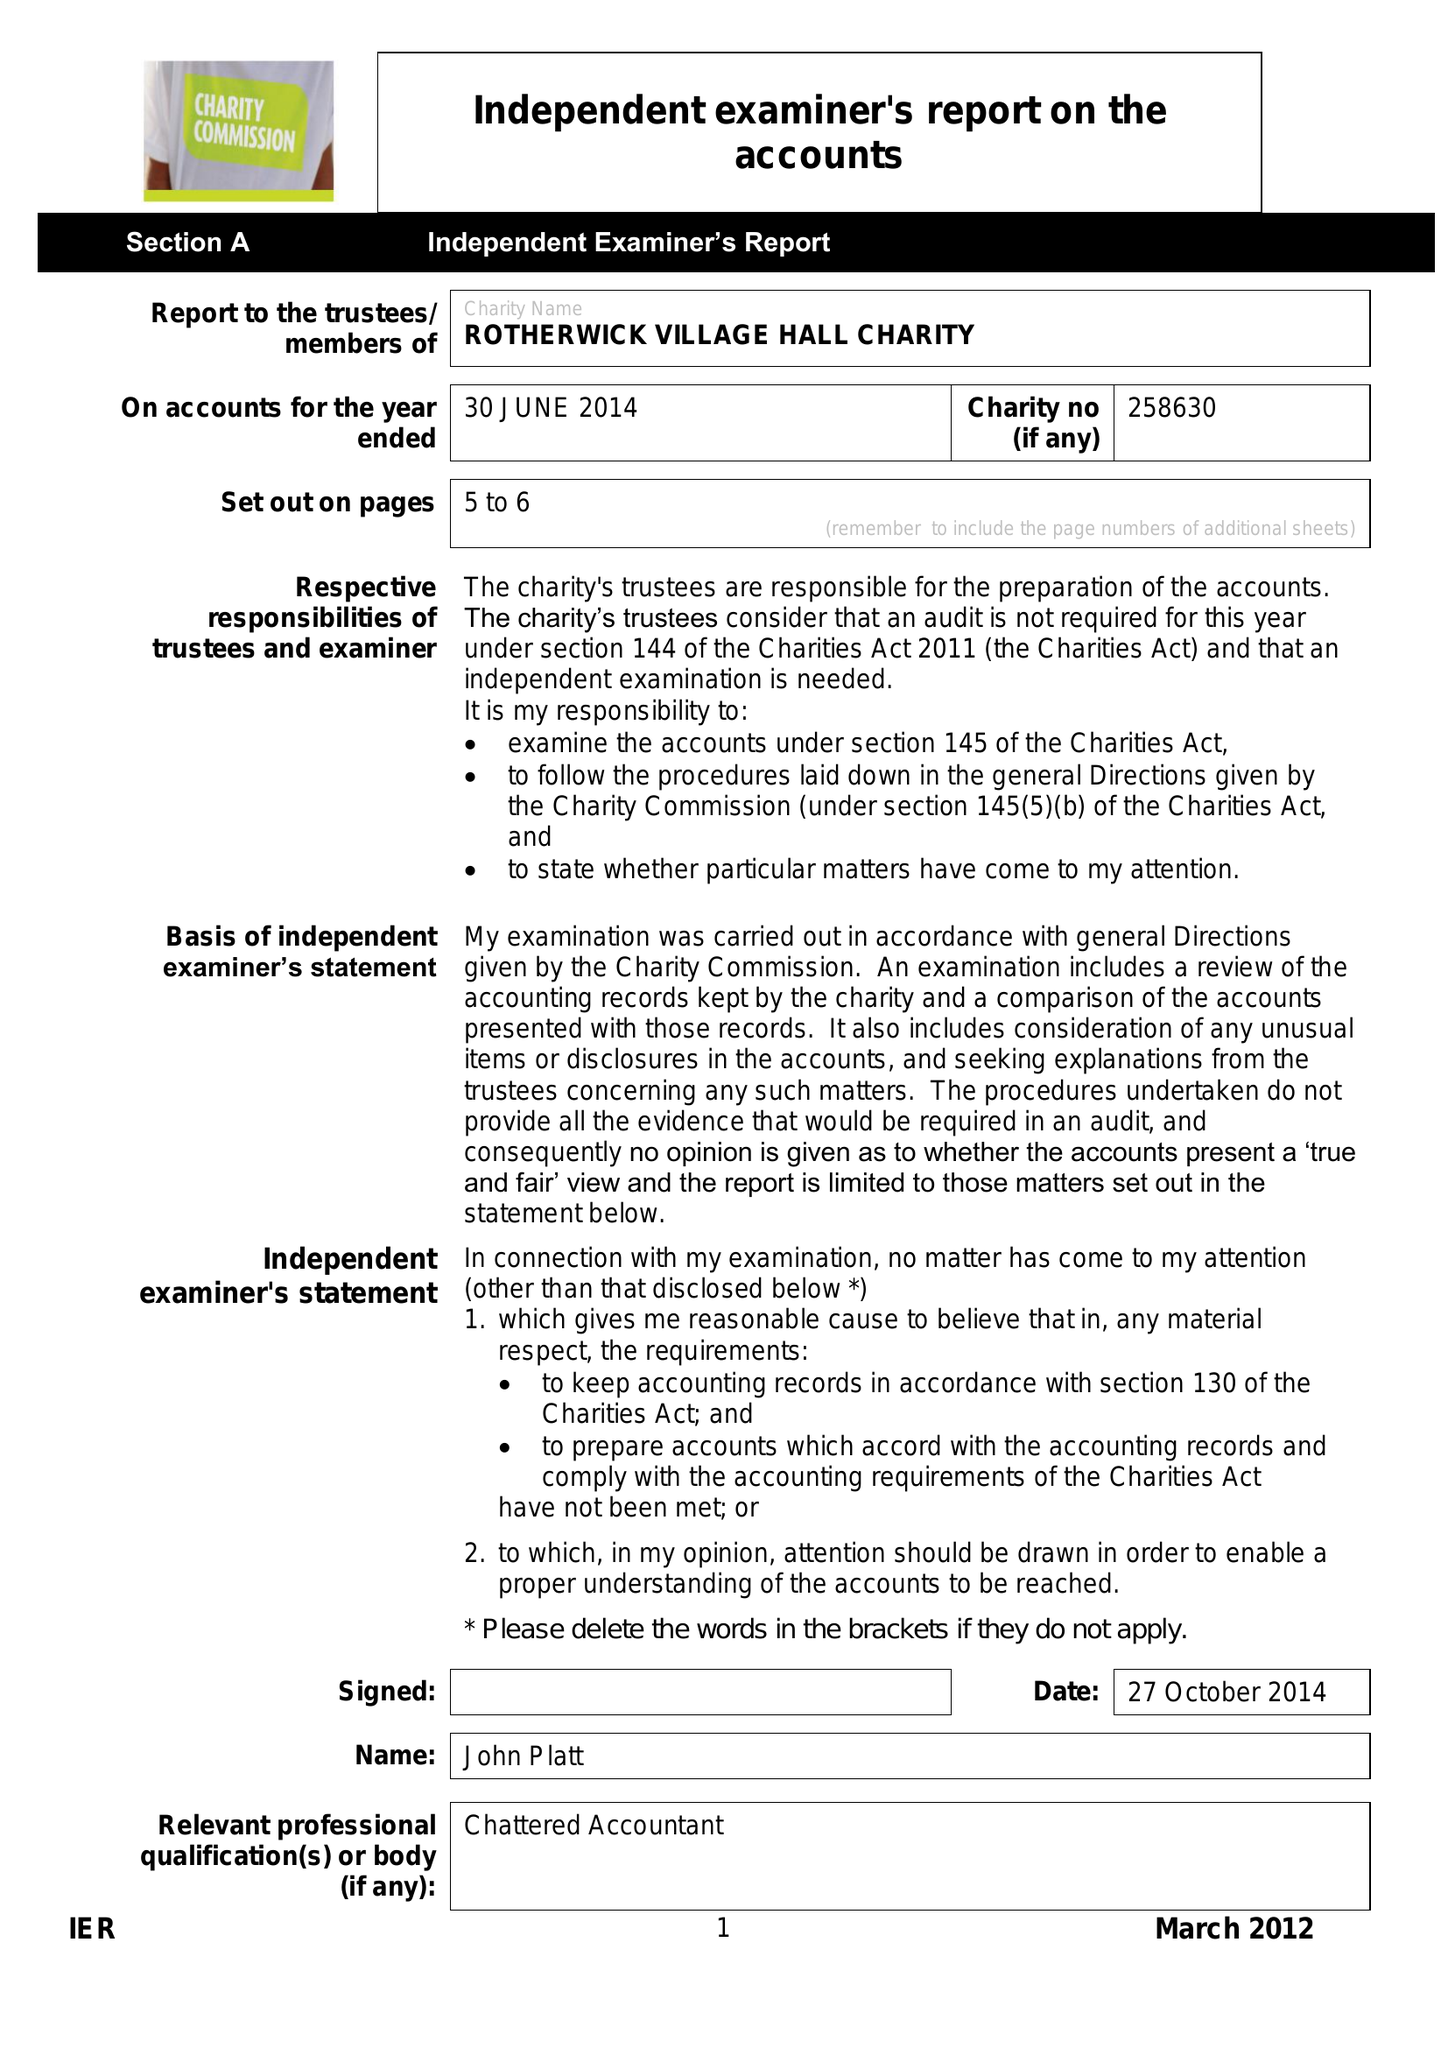What is the value for the charity_number?
Answer the question using a single word or phrase. 258630 